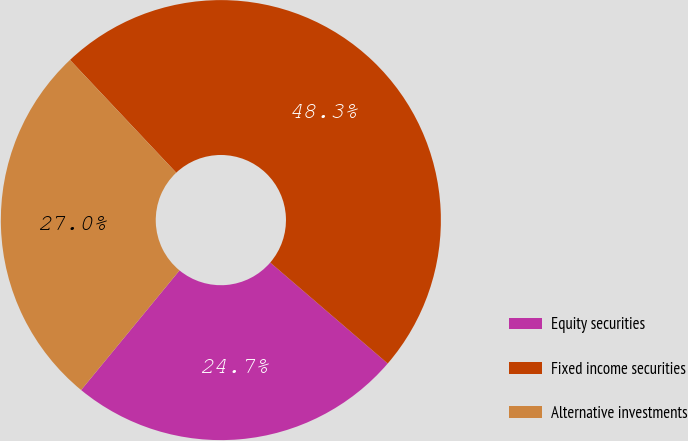Convert chart to OTSL. <chart><loc_0><loc_0><loc_500><loc_500><pie_chart><fcel>Equity securities<fcel>Fixed income securities<fcel>Alternative investments<nl><fcel>24.65%<fcel>48.32%<fcel>27.02%<nl></chart> 